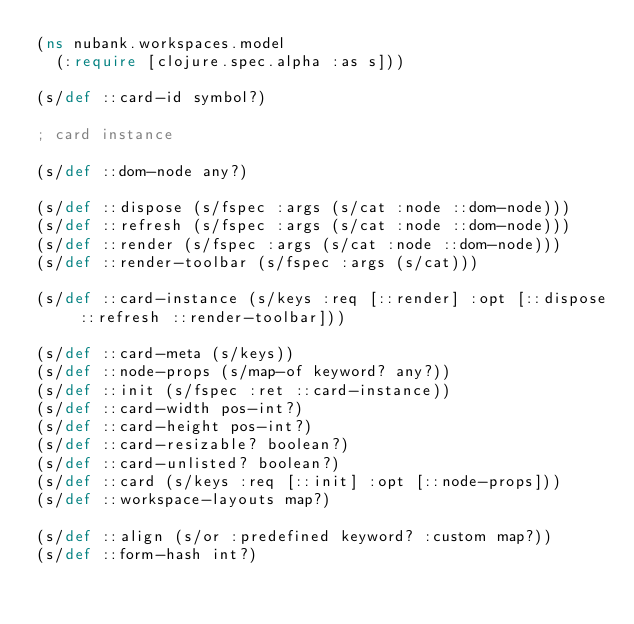<code> <loc_0><loc_0><loc_500><loc_500><_Clojure_>(ns nubank.workspaces.model
  (:require [clojure.spec.alpha :as s]))

(s/def ::card-id symbol?)

; card instance

(s/def ::dom-node any?)

(s/def ::dispose (s/fspec :args (s/cat :node ::dom-node)))
(s/def ::refresh (s/fspec :args (s/cat :node ::dom-node)))
(s/def ::render (s/fspec :args (s/cat :node ::dom-node)))
(s/def ::render-toolbar (s/fspec :args (s/cat)))

(s/def ::card-instance (s/keys :req [::render] :opt [::dispose ::refresh ::render-toolbar]))

(s/def ::card-meta (s/keys))
(s/def ::node-props (s/map-of keyword? any?))
(s/def ::init (s/fspec :ret ::card-instance))
(s/def ::card-width pos-int?)
(s/def ::card-height pos-int?)
(s/def ::card-resizable? boolean?)
(s/def ::card-unlisted? boolean?)
(s/def ::card (s/keys :req [::init] :opt [::node-props]))
(s/def ::workspace-layouts map?)

(s/def ::align (s/or :predefined keyword? :custom map?))
(s/def ::form-hash int?)
</code> 